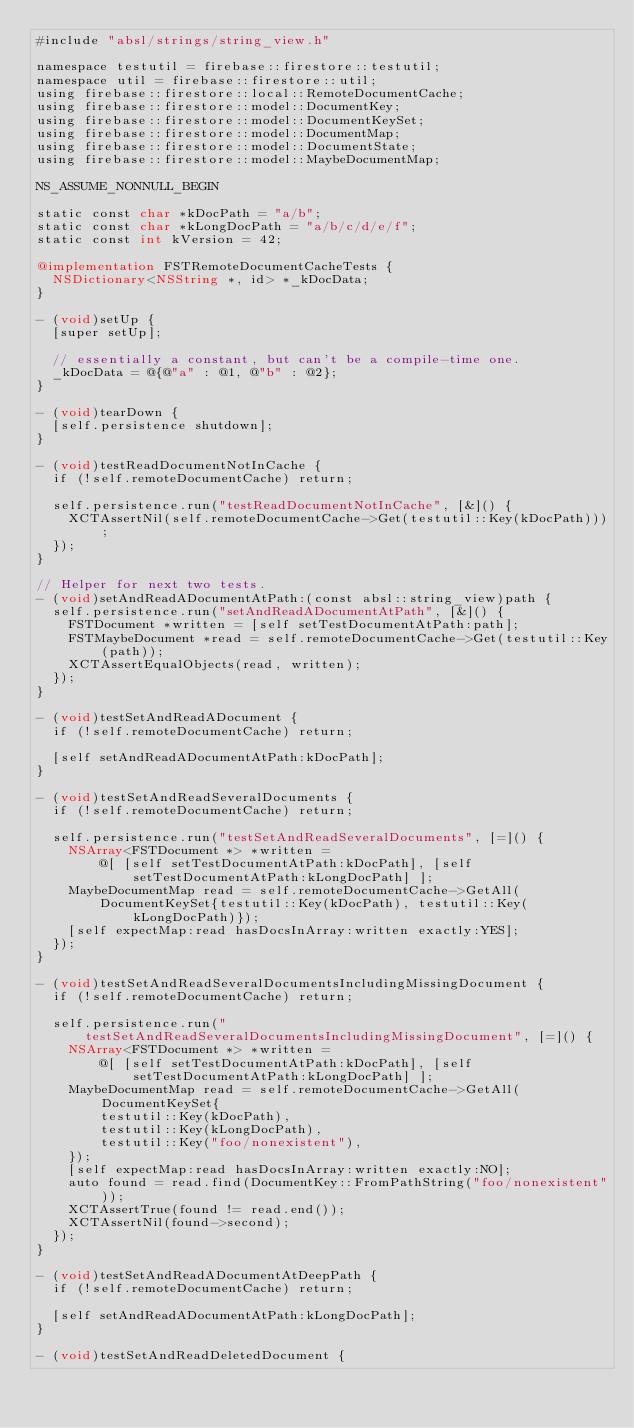Convert code to text. <code><loc_0><loc_0><loc_500><loc_500><_ObjectiveC_>#include "absl/strings/string_view.h"

namespace testutil = firebase::firestore::testutil;
namespace util = firebase::firestore::util;
using firebase::firestore::local::RemoteDocumentCache;
using firebase::firestore::model::DocumentKey;
using firebase::firestore::model::DocumentKeySet;
using firebase::firestore::model::DocumentMap;
using firebase::firestore::model::DocumentState;
using firebase::firestore::model::MaybeDocumentMap;

NS_ASSUME_NONNULL_BEGIN

static const char *kDocPath = "a/b";
static const char *kLongDocPath = "a/b/c/d/e/f";
static const int kVersion = 42;

@implementation FSTRemoteDocumentCacheTests {
  NSDictionary<NSString *, id> *_kDocData;
}

- (void)setUp {
  [super setUp];

  // essentially a constant, but can't be a compile-time one.
  _kDocData = @{@"a" : @1, @"b" : @2};
}

- (void)tearDown {
  [self.persistence shutdown];
}

- (void)testReadDocumentNotInCache {
  if (!self.remoteDocumentCache) return;

  self.persistence.run("testReadDocumentNotInCache", [&]() {
    XCTAssertNil(self.remoteDocumentCache->Get(testutil::Key(kDocPath)));
  });
}

// Helper for next two tests.
- (void)setAndReadADocumentAtPath:(const absl::string_view)path {
  self.persistence.run("setAndReadADocumentAtPath", [&]() {
    FSTDocument *written = [self setTestDocumentAtPath:path];
    FSTMaybeDocument *read = self.remoteDocumentCache->Get(testutil::Key(path));
    XCTAssertEqualObjects(read, written);
  });
}

- (void)testSetAndReadADocument {
  if (!self.remoteDocumentCache) return;

  [self setAndReadADocumentAtPath:kDocPath];
}

- (void)testSetAndReadSeveralDocuments {
  if (!self.remoteDocumentCache) return;

  self.persistence.run("testSetAndReadSeveralDocuments", [=]() {
    NSArray<FSTDocument *> *written =
        @[ [self setTestDocumentAtPath:kDocPath], [self setTestDocumentAtPath:kLongDocPath] ];
    MaybeDocumentMap read = self.remoteDocumentCache->GetAll(
        DocumentKeySet{testutil::Key(kDocPath), testutil::Key(kLongDocPath)});
    [self expectMap:read hasDocsInArray:written exactly:YES];
  });
}

- (void)testSetAndReadSeveralDocumentsIncludingMissingDocument {
  if (!self.remoteDocumentCache) return;

  self.persistence.run("testSetAndReadSeveralDocumentsIncludingMissingDocument", [=]() {
    NSArray<FSTDocument *> *written =
        @[ [self setTestDocumentAtPath:kDocPath], [self setTestDocumentAtPath:kLongDocPath] ];
    MaybeDocumentMap read = self.remoteDocumentCache->GetAll(DocumentKeySet{
        testutil::Key(kDocPath),
        testutil::Key(kLongDocPath),
        testutil::Key("foo/nonexistent"),
    });
    [self expectMap:read hasDocsInArray:written exactly:NO];
    auto found = read.find(DocumentKey::FromPathString("foo/nonexistent"));
    XCTAssertTrue(found != read.end());
    XCTAssertNil(found->second);
  });
}

- (void)testSetAndReadADocumentAtDeepPath {
  if (!self.remoteDocumentCache) return;

  [self setAndReadADocumentAtPath:kLongDocPath];
}

- (void)testSetAndReadDeletedDocument {</code> 